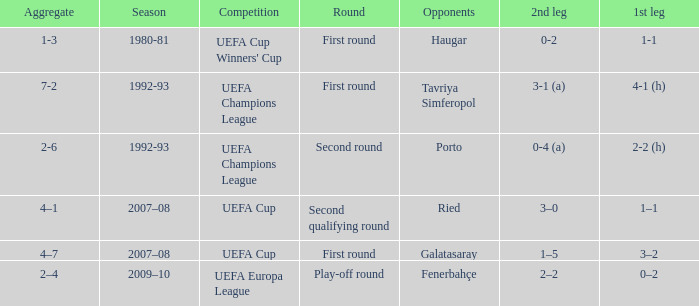What is the total number of round where opponents is haugar 1.0. 